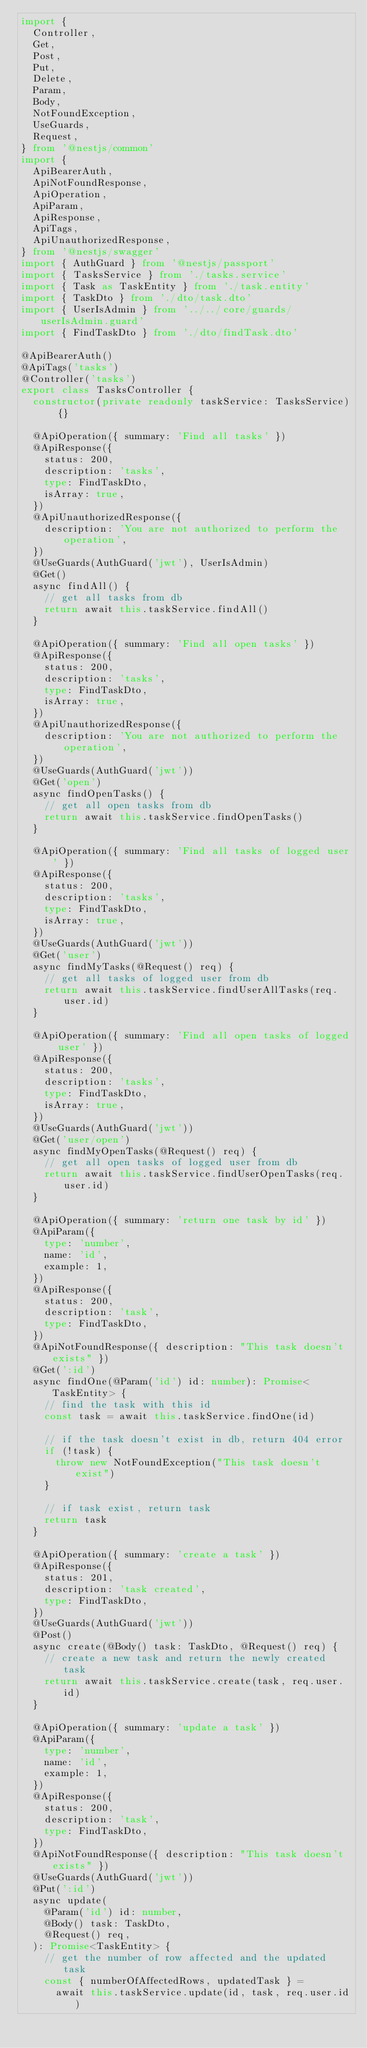<code> <loc_0><loc_0><loc_500><loc_500><_TypeScript_>import {
	Controller,
	Get,
	Post,
	Put,
	Delete,
	Param,
	Body,
	NotFoundException,
	UseGuards,
	Request,
} from '@nestjs/common'
import {
	ApiBearerAuth,
	ApiNotFoundResponse,
	ApiOperation,
	ApiParam,
	ApiResponse,
	ApiTags,
	ApiUnauthorizedResponse,
} from '@nestjs/swagger'
import { AuthGuard } from '@nestjs/passport'
import { TasksService } from './tasks.service'
import { Task as TaskEntity } from './task.entity'
import { TaskDto } from './dto/task.dto'
import { UserIsAdmin } from '../../core/guards/userIsAdmin.guard'
import { FindTaskDto } from './dto/findTask.dto'

@ApiBearerAuth()
@ApiTags('tasks')
@Controller('tasks')
export class TasksController {
	constructor(private readonly taskService: TasksService) {}

	@ApiOperation({ summary: 'Find all tasks' })
	@ApiResponse({
		status: 200,
		description: 'tasks',
		type: FindTaskDto,
		isArray: true,
	})
	@ApiUnauthorizedResponse({
		description: 'You are not authorized to perform the operation',
	})
	@UseGuards(AuthGuard('jwt'), UserIsAdmin)
	@Get()
	async findAll() {
		// get all tasks from db
		return await this.taskService.findAll()
	}

	@ApiOperation({ summary: 'Find all open tasks' })
	@ApiResponse({
		status: 200,
		description: 'tasks',
		type: FindTaskDto,
		isArray: true,
	})
	@ApiUnauthorizedResponse({
		description: 'You are not authorized to perform the operation',
	})
	@UseGuards(AuthGuard('jwt'))
	@Get('open')
	async findOpenTasks() {
		// get all open tasks from db
		return await this.taskService.findOpenTasks()
	}

	@ApiOperation({ summary: 'Find all tasks of logged user' })
	@ApiResponse({
		status: 200,
		description: 'tasks',
		type: FindTaskDto,
		isArray: true,
	})
	@UseGuards(AuthGuard('jwt'))
	@Get('user')
	async findMyTasks(@Request() req) {
		// get all tasks of logged user from db
		return await this.taskService.findUserAllTasks(req.user.id)
	}

	@ApiOperation({ summary: 'Find all open tasks of logged user' })
	@ApiResponse({
		status: 200,
		description: 'tasks',
		type: FindTaskDto,
		isArray: true,
	})
	@UseGuards(AuthGuard('jwt'))
	@Get('user/open')
	async findMyOpenTasks(@Request() req) {
		// get all open tasks of logged user from db
		return await this.taskService.findUserOpenTasks(req.user.id)
	}

	@ApiOperation({ summary: 'return one task by id' })
	@ApiParam({
		type: 'number',
		name: 'id',
		example: 1,
	})
	@ApiResponse({
		status: 200,
		description: 'task',
		type: FindTaskDto,
	})
	@ApiNotFoundResponse({ description: "This task doesn't exists" })
	@Get(':id')
	async findOne(@Param('id') id: number): Promise<TaskEntity> {
		// find the task with this id
		const task = await this.taskService.findOne(id)

		// if the task doesn't exist in db, return 404 error
		if (!task) {
			throw new NotFoundException("This task doesn't exist")
		}

		// if task exist, return task
		return task
	}

	@ApiOperation({ summary: 'create a task' })
	@ApiResponse({
		status: 201,
		description: 'task created',
		type: FindTaskDto,
	})
	@UseGuards(AuthGuard('jwt'))
	@Post()
	async create(@Body() task: TaskDto, @Request() req) {
		// create a new task and return the newly created task
		return await this.taskService.create(task, req.user.id)
	}

	@ApiOperation({ summary: 'update a task' })
	@ApiParam({
		type: 'number',
		name: 'id',
		example: 1,
	})
	@ApiResponse({
		status: 200,
		description: 'task',
		type: FindTaskDto,
	})
	@ApiNotFoundResponse({ description: "This task doesn't exists" })
	@UseGuards(AuthGuard('jwt'))
	@Put(':id')
	async update(
		@Param('id') id: number,
		@Body() task: TaskDto,
		@Request() req,
	): Promise<TaskEntity> {
		// get the number of row affected and the updated task
		const { numberOfAffectedRows, updatedTask } =
			await this.taskService.update(id, task, req.user.id)
</code> 